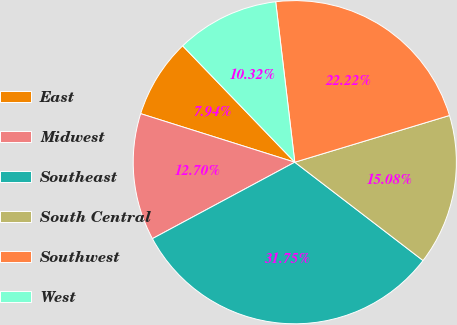Convert chart to OTSL. <chart><loc_0><loc_0><loc_500><loc_500><pie_chart><fcel>East<fcel>Midwest<fcel>Southeast<fcel>South Central<fcel>Southwest<fcel>West<nl><fcel>7.94%<fcel>12.7%<fcel>31.75%<fcel>15.08%<fcel>22.22%<fcel>10.32%<nl></chart> 